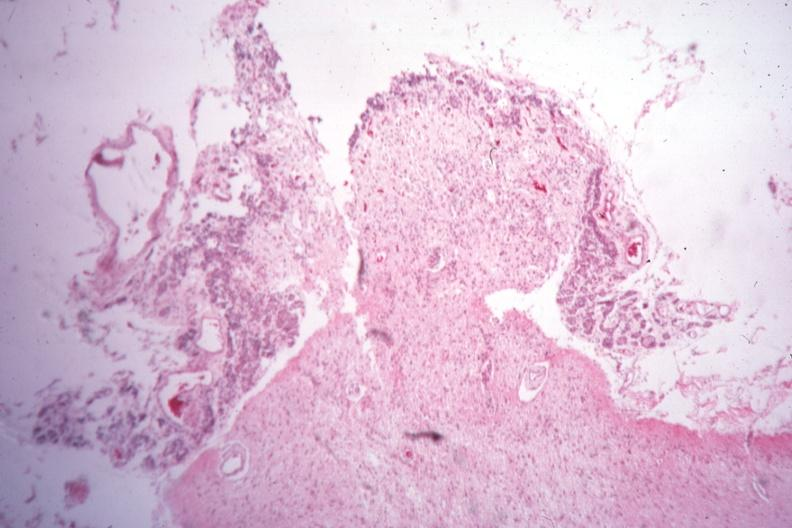s quite good liver present?
Answer the question using a single word or phrase. No 